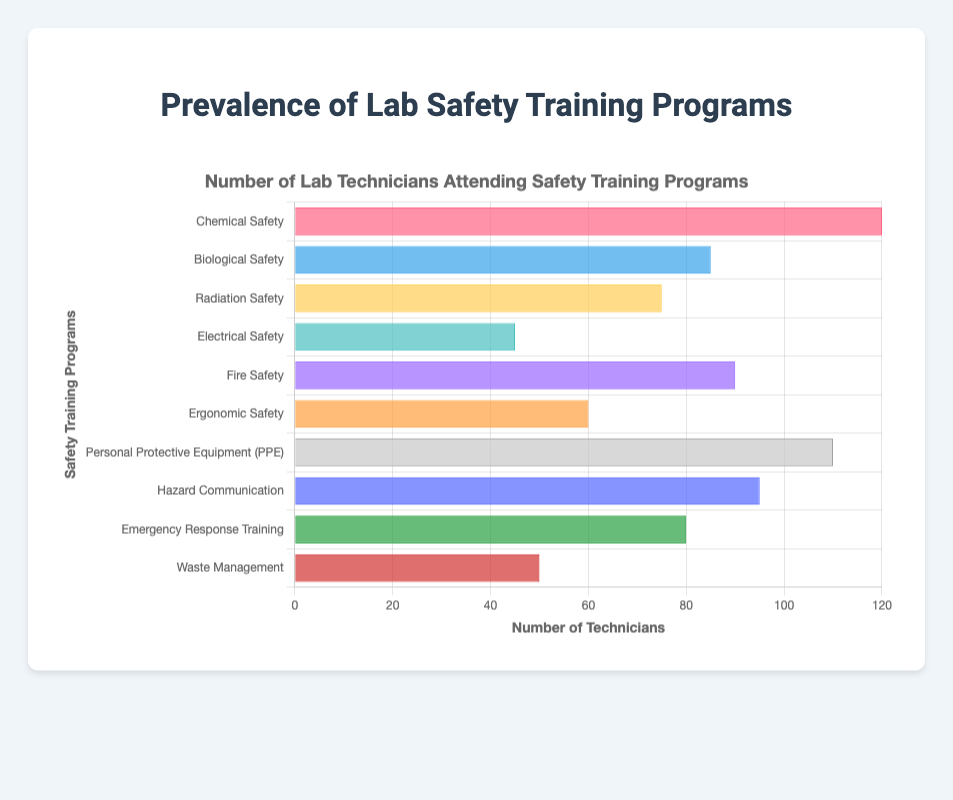Which safety training program had the highest number of technicians attending? To find this, look for the longest bar on the chart or the highest value on the x-axis. In this case, the "Chemical Safety" program has the highest number of technicians attending with 120.
Answer: Chemical Safety What is the difference in the number of technicians attending the "Radiation Safety" and "Fire Safety" programs? Check the values for both programs: "Radiation Safety" has 75 technicians, and "Fire Safety" has 90 technicians. Subtract the smaller number from the larger: 90 - 75 = 15.
Answer: 15 How many technicians attended both the "Personal Protective Equipment (PPE)" and "Ergonomic Safety" programs combined? Find the number of technicians for both programs: "PPE" has 110 and "Ergonomic Safety" has 60. Add the two numbers together: 110 + 60 = 170.
Answer: 170 Which program had fewer technicians attending: "Waste Management" or "Electrical Safety"? Compare the lengths of the bars or the values: "Waste Management" has 50 technicians, while "Electrical Safety" has 45. Thus, "Electrical Safety" has fewer technicians.
Answer: Electrical Safety What is the average number of technicians attending the "Biological Safety", "Emergency Response Training", and "Hazard Communication" programs? Find the number of technicians for the three programs: "Biological Safety" has 85, "Emergency Response Training" has 80, and "Hazard Communication" has 95. Add the numbers together (85 + 80 + 95 = 260) and divide by 3. The average is 260 / 3 ≈ 86.67.
Answer: 86.67 Which safety training program had the shortest bar on the chart? The shortest bar will correspond to the program with the least number of technicians attending. Here, the "Electrical Safety" program has the fewest technicians with 45.
Answer: Electrical Safety How many more technicians attended the "Chemical Safety" program compared to the "Emergency Response Training" program? Find the number of technicians for both programs: "Chemical Safety" has 120, and "Emergency Response Training" has 80. Subtract the smaller number from the larger: 120 - 80 = 40.
Answer: 40 Which training program had a higher attendance: "Hazard Communication" or "Personal Protective Equipment (PPE)"? Compare the values for both programs: "Hazard Communication" has 95, and "PPE" has 110. "PPE" had higher attendance.
Answer: Personal Protective Equipment (PPE) What is the total number of technicians who attended the "Chemical Safety", "Biological Safety", and "Radiation Safety" programs? Add the number of technicians for each program: "Chemical Safety" has 120, "Biological Safety" has 85, and "Radiation Safety" has 75. The total is 120 + 85 + 75 = 280.
Answer: 280 